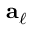Convert formula to latex. <formula><loc_0><loc_0><loc_500><loc_500>{ a } _ { \ell }</formula> 